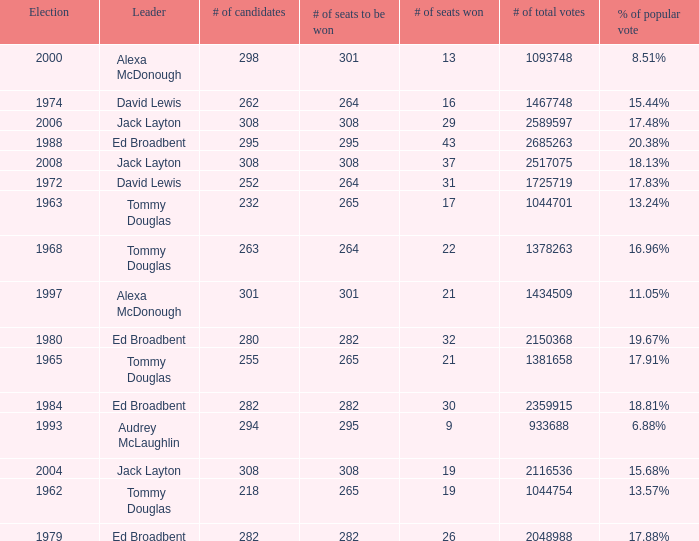Name the number of leaders for % of popular vote being 11.05% 1.0. Help me parse the entirety of this table. {'header': ['Election', 'Leader', '# of candidates', '# of seats to be won', '# of seats won', '# of total votes', '% of popular vote'], 'rows': [['2000', 'Alexa McDonough', '298', '301', '13', '1093748', '8.51%'], ['1974', 'David Lewis', '262', '264', '16', '1467748', '15.44%'], ['2006', 'Jack Layton', '308', '308', '29', '2589597', '17.48%'], ['1988', 'Ed Broadbent', '295', '295', '43', '2685263', '20.38%'], ['2008', 'Jack Layton', '308', '308', '37', '2517075', '18.13%'], ['1972', 'David Lewis', '252', '264', '31', '1725719', '17.83%'], ['1963', 'Tommy Douglas', '232', '265', '17', '1044701', '13.24%'], ['1968', 'Tommy Douglas', '263', '264', '22', '1378263', '16.96%'], ['1997', 'Alexa McDonough', '301', '301', '21', '1434509', '11.05%'], ['1980', 'Ed Broadbent', '280', '282', '32', '2150368', '19.67%'], ['1965', 'Tommy Douglas', '255', '265', '21', '1381658', '17.91%'], ['1984', 'Ed Broadbent', '282', '282', '30', '2359915', '18.81%'], ['1993', 'Audrey McLaughlin', '294', '295', '9', '933688', '6.88%'], ['2004', 'Jack Layton', '308', '308', '19', '2116536', '15.68%'], ['1962', 'Tommy Douglas', '218', '265', '19', '1044754', '13.57%'], ['1979', 'Ed Broadbent', '282', '282', '26', '2048988', '17.88%']]} 